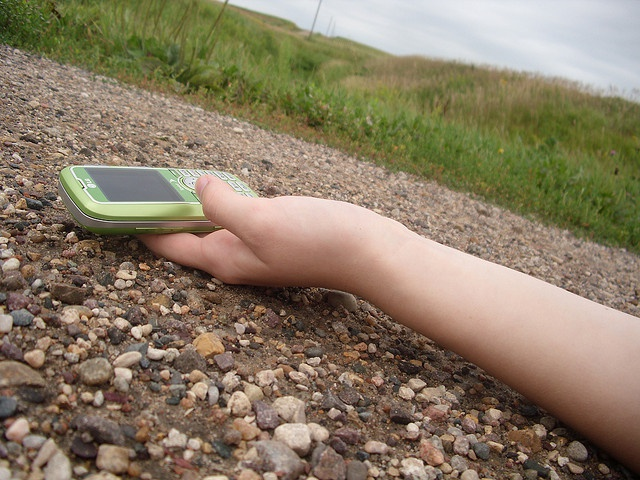Describe the objects in this image and their specific colors. I can see people in darkgreen, tan, lightgray, and gray tones and cell phone in darkgreen, gray, khaki, and darkgray tones in this image. 